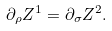Convert formula to latex. <formula><loc_0><loc_0><loc_500><loc_500>\partial _ { \rho } { Z } ^ { 1 } = \partial _ { \sigma } { Z } ^ { 2 } .</formula> 